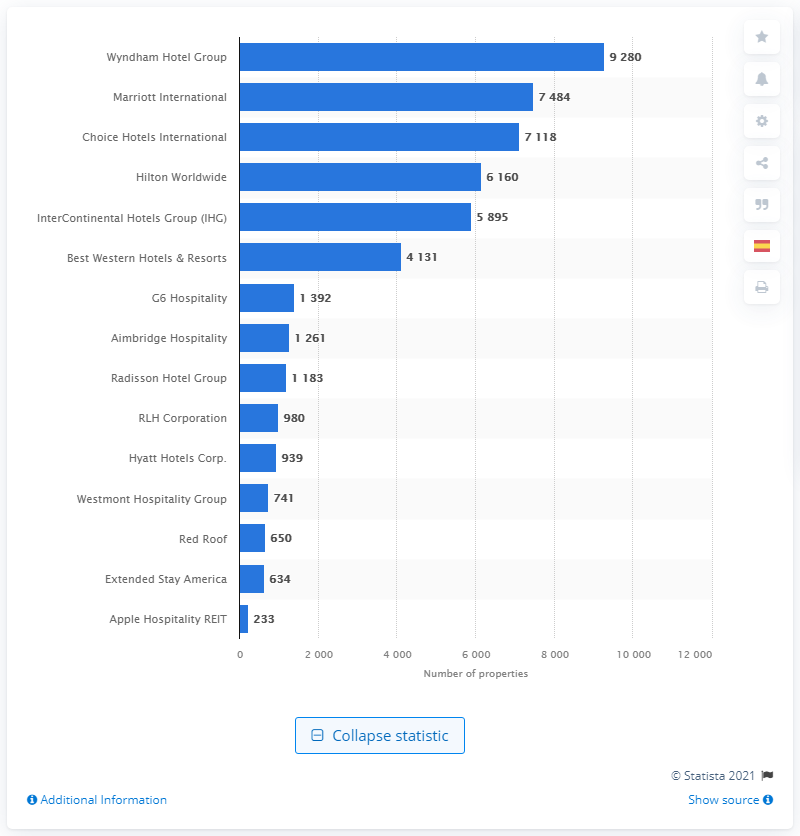Identify some key points in this picture. Wyndham Hotel Group is the leading hotel chain in terms of the number of properties, and it ranks at the top among the top hotel companies. 